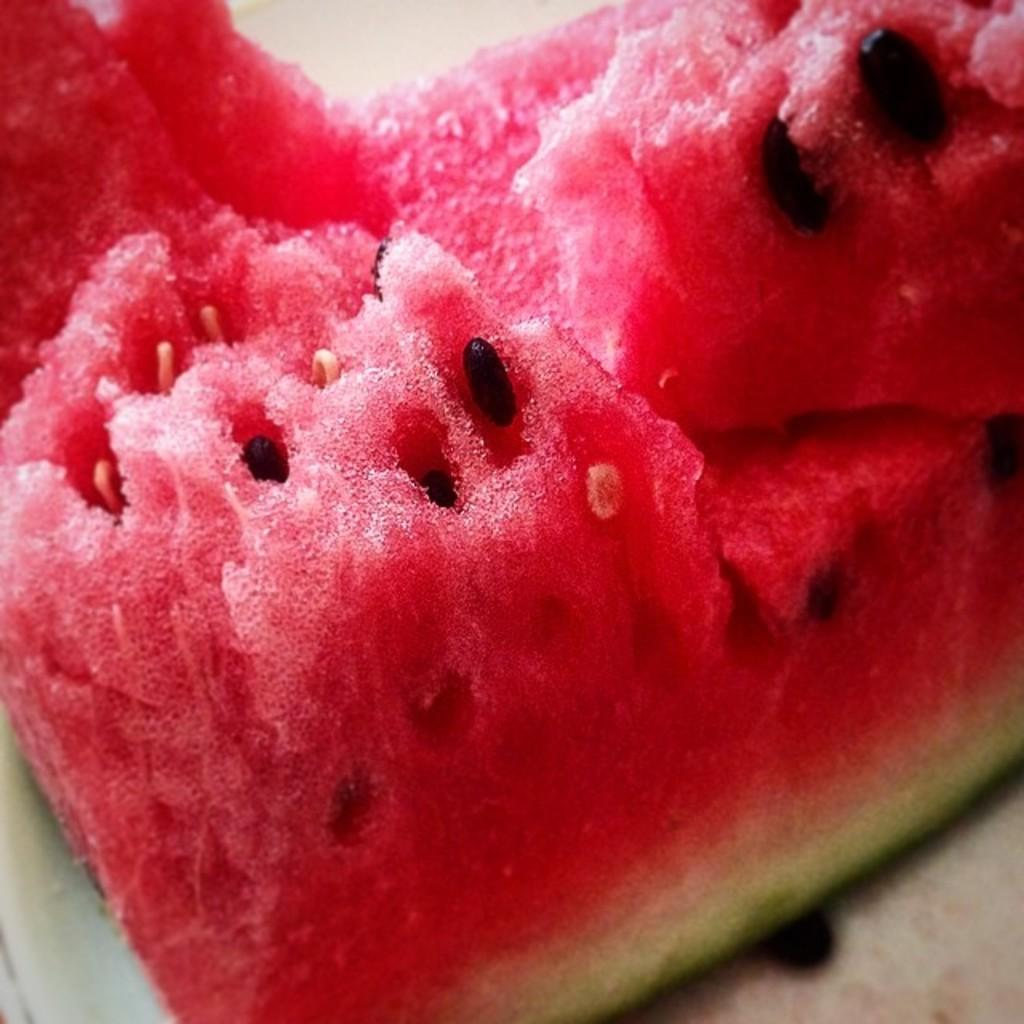What type of fruit is shown in the image? There is a slice of watermelon in the image. Can you describe the appearance of the watermelon slice? There are seeds visible in the watermelon slice. What design is featured on the notebook in the image? There is no notebook present in the image; it only shows a slice of watermelon with visible seeds. 